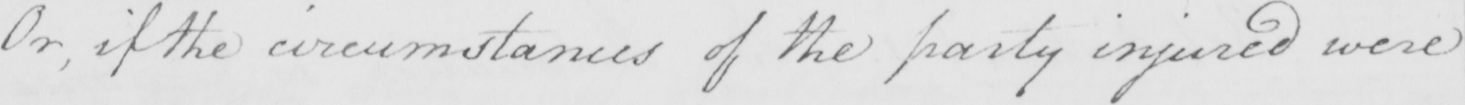Please transcribe the handwritten text in this image. Or , if the circumstances of the party injured were 